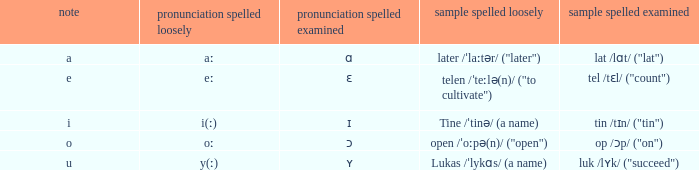What is Example Spelled Free, when Example Spelled Checked is "op /ɔp/ ("on")"? Open /ˈoːpə(n)/ ("open"). 